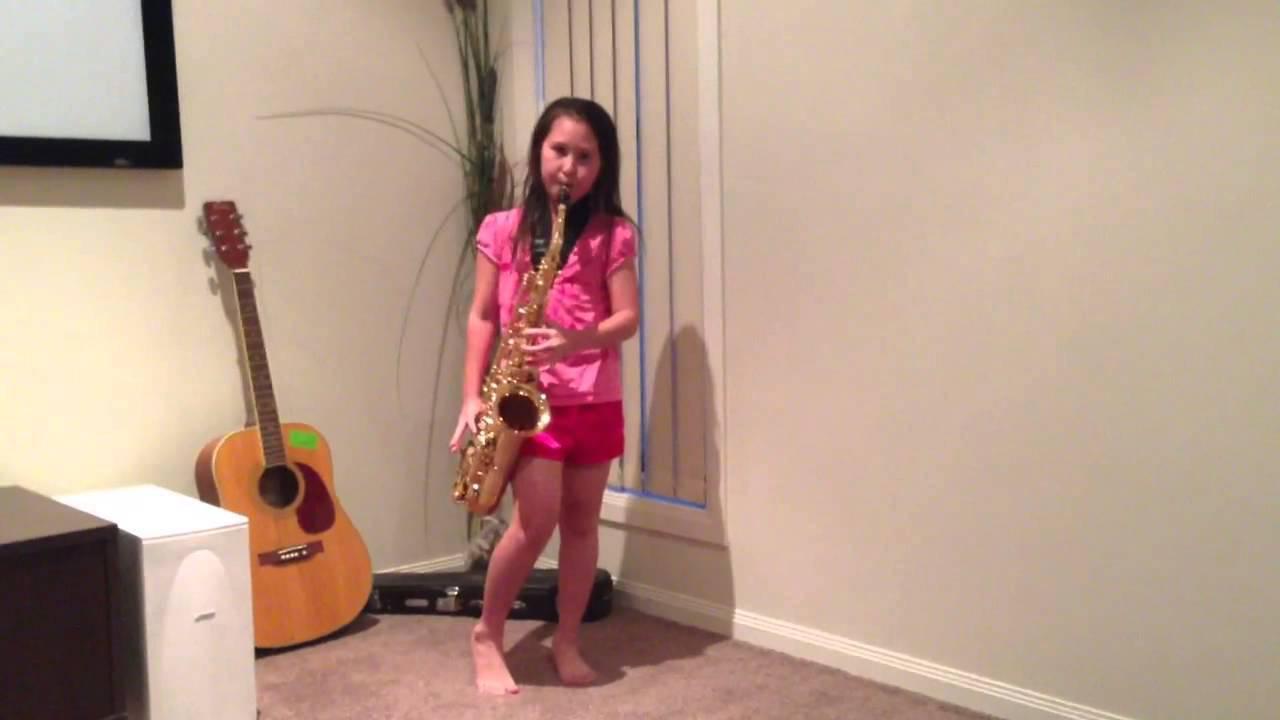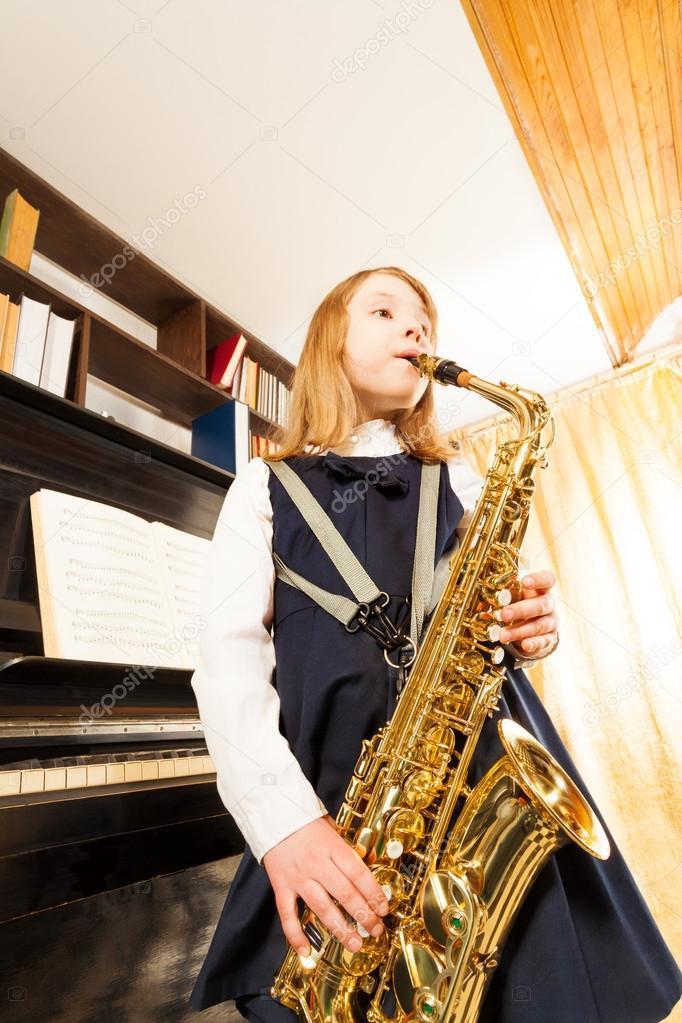The first image is the image on the left, the second image is the image on the right. Considering the images on both sides, is "The saxophone in each of the images is being played by a female child." valid? Answer yes or no. Yes. The first image is the image on the left, the second image is the image on the right. Given the left and right images, does the statement "Each image shows a female child holding a saxophone." hold true? Answer yes or no. Yes. 